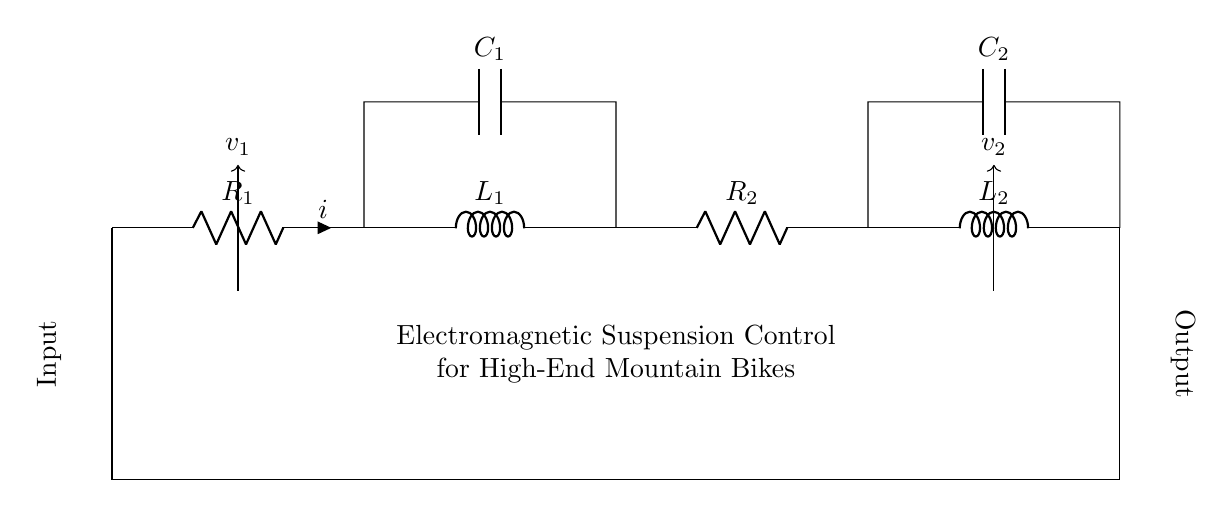What are the components in this circuit? The circuit contains two resistors, two inductors, and two capacitors. Specifically, R1, R2 denote the resistors, L1, L2 the inductors, and C1, C2 the capacitors.
Answer: Resistors, inductors, capacitors What is the total number of energy storage elements in this circuit? Energy storage elements in this circuit include inductors and capacitors. There are two inductors (L1, L2) and two capacitors (C1, C2), totaling four energy storage elements.
Answer: Four What is the expected function of this resistor-inductor network? The network serves to control electromagnetic suspension in high-end mountain bikes, optimizing the performance of the suspension system.
Answer: Electromagnetic suspension control Which component provides voltage stabilization in this circuit? The capacitors (C1 and C2) play a crucial role in voltage stabilization by smoothing out voltage fluctuations in the circuit.
Answer: Capacitors What happens if the resistance of R1 is increased? Increasing the resistance of R1 will lower the overall current in the circuit, leading to reduced energy transfer to the inductors and potentially affecting the suspension control performance.
Answer: Current decreases What is the relationship between voltage and current in the inductors? The voltage across an inductor is directly proportional to the rate of change of current through it, according to the equation v = L(di/dt), meaning that inductors resist changes in current.
Answer: Voltage proportional to rate of change of current How are the components connected in this circuit? The components are connected in series, where the current flows sequentially through R1, L1, R2, L2, followed by their respective capacitors that are parallel to each inductor.
Answer: Series circuit connections 